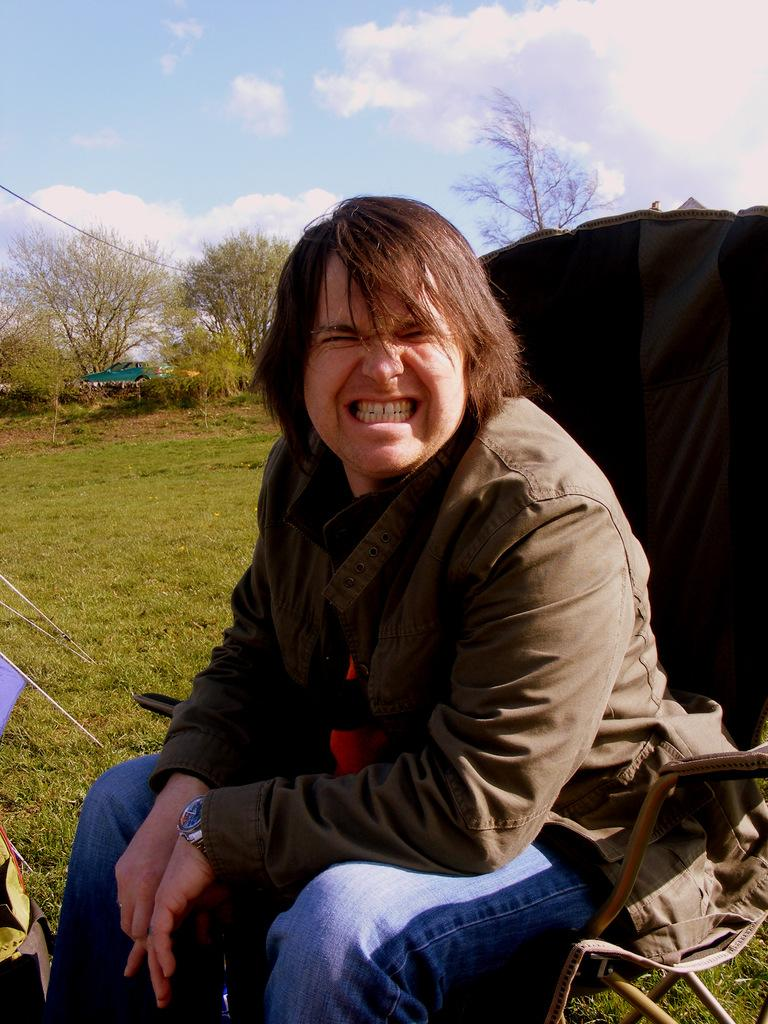What is the main subject of the image? There is a person in the image. What is the person doing in the image? The person is sitting on a chair. What can be seen in the background of the image? There are trees visible in the background of the image. What type of haircut does the person have in the image? There is no information about the person's haircut in the image. Is the person in motion in the image? The person is not in motion in the image; they are sitting on a chair. 